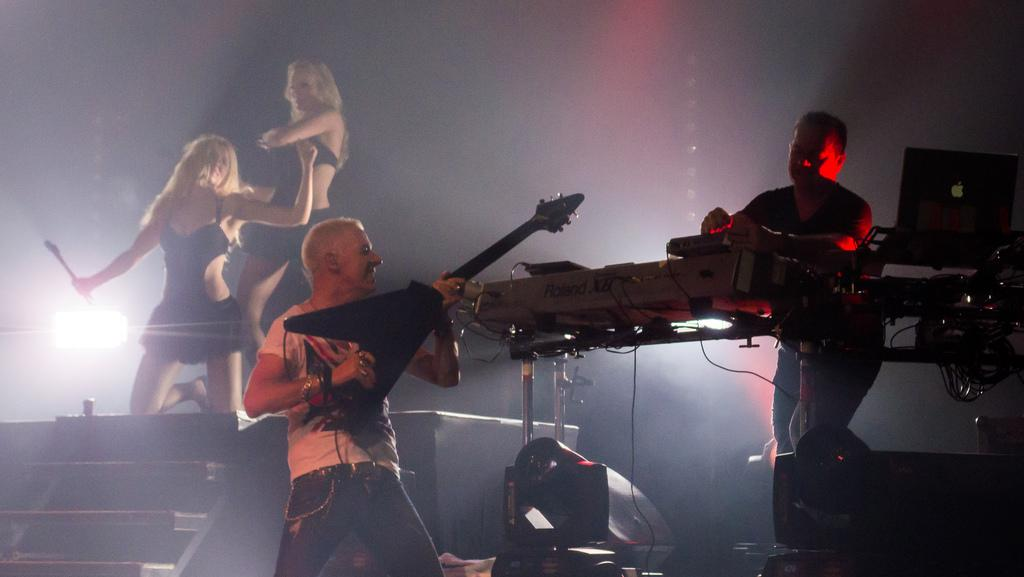What are the two people in the image doing? The two people in the image are playing musical instruments. What are the girls in the image doing? The girls in the image are dancing. What type of meat is being traded by the lawyer in the image? There is no lawyer or meat present in the image; it features two people playing musical instruments and two girls dancing. 